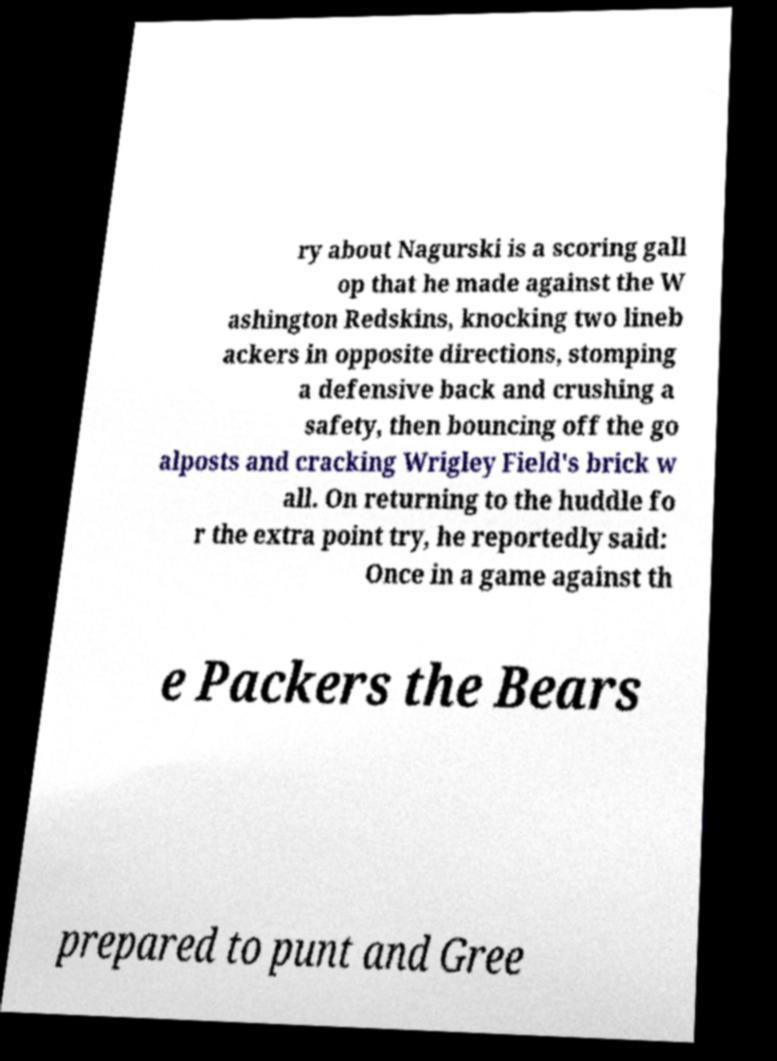I need the written content from this picture converted into text. Can you do that? ry about Nagurski is a scoring gall op that he made against the W ashington Redskins, knocking two lineb ackers in opposite directions, stomping a defensive back and crushing a safety, then bouncing off the go alposts and cracking Wrigley Field's brick w all. On returning to the huddle fo r the extra point try, he reportedly said: Once in a game against th e Packers the Bears prepared to punt and Gree 